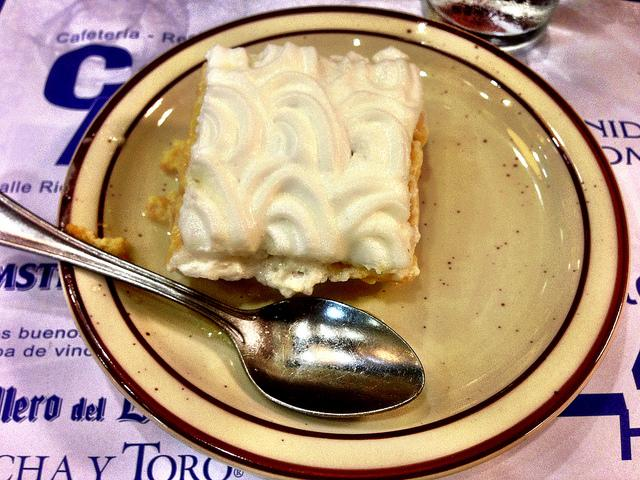What is on the plate?

Choices:
A) apple
B) chicken leg
C) spoon
D) salmon spoon 